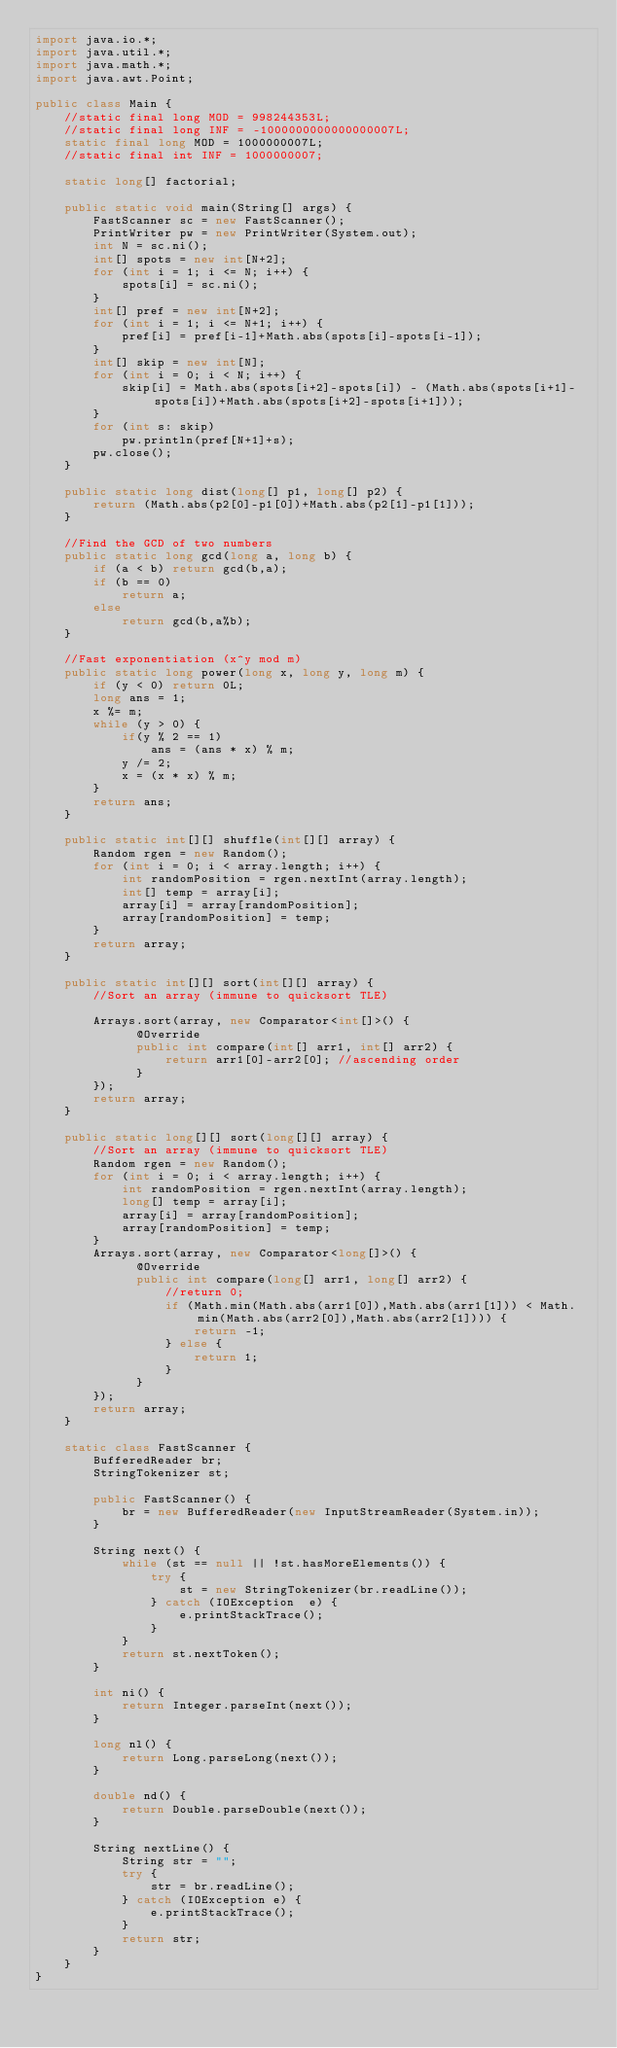<code> <loc_0><loc_0><loc_500><loc_500><_Java_>import java.io.*;
import java.util.*;
import java.math.*;
import java.awt.Point;
 
public class Main {
	//static final long MOD = 998244353L;
	//static final long INF = -1000000000000000007L;
	static final long MOD = 1000000007L;
	//static final int INF = 1000000007;
	
	static long[] factorial;
	
	public static void main(String[] args) {
		FastScanner sc = new FastScanner();
		PrintWriter pw = new PrintWriter(System.out);
		int N = sc.ni();
		int[] spots = new int[N+2];
		for (int i = 1; i <= N; i++) {
			spots[i] = sc.ni();
		}
		int[] pref = new int[N+2];
		for (int i = 1; i <= N+1; i++) {
			pref[i] = pref[i-1]+Math.abs(spots[i]-spots[i-1]);
		}
		int[] skip = new int[N];
		for (int i = 0; i < N; i++) {
			skip[i] = Math.abs(spots[i+2]-spots[i]) - (Math.abs(spots[i+1]-spots[i])+Math.abs(spots[i+2]-spots[i+1]));
		}
		for (int s: skip)
			pw.println(pref[N+1]+s);
		pw.close();
	}
	
	public static long dist(long[] p1, long[] p2) {
		return (Math.abs(p2[0]-p1[0])+Math.abs(p2[1]-p1[1]));
	}
	
	//Find the GCD of two numbers
	public static long gcd(long a, long b) {
		if (a < b) return gcd(b,a);
		if (b == 0)
			return a;
		else
			return gcd(b,a%b);
	}
	
	//Fast exponentiation (x^y mod m)
	public static long power(long x, long y, long m) { 
		if (y < 0) return 0L;
		long ans = 1;
		x %= m;
		while (y > 0) { 
			if(y % 2 == 1) 
				ans = (ans * x) % m; 
			y /= 2;  
			x = (x * x) % m;
		} 
		return ans; 
	}
	
	public static int[][] shuffle(int[][] array) {
		Random rgen = new Random();
		for (int i = 0; i < array.length; i++) {
		    int randomPosition = rgen.nextInt(array.length);
		    int[] temp = array[i];
		    array[i] = array[randomPosition];
		    array[randomPosition] = temp;
		}
		return array;
	}
	
    public static int[][] sort(int[][] array) {
    	//Sort an array (immune to quicksort TLE)
 
		Arrays.sort(array, new Comparator<int[]>() {
			  @Override
        	  public int compare(int[] arr1, int[] arr2) {
				  return arr1[0]-arr2[0]; //ascending order
	          }
		});
		return array;
	}
    
    public static long[][] sort(long[][] array) {
    	//Sort an array (immune to quicksort TLE)
		Random rgen = new Random();
		for (int i = 0; i < array.length; i++) {
		    int randomPosition = rgen.nextInt(array.length);
		    long[] temp = array[i];
		    array[i] = array[randomPosition];
		    array[randomPosition] = temp;
		}
		Arrays.sort(array, new Comparator<long[]>() {
			  @Override
        	  public int compare(long[] arr1, long[] arr2) {
				  //return 0;
				  if (Math.min(Math.abs(arr1[0]),Math.abs(arr1[1])) < Math.min(Math.abs(arr2[0]),Math.abs(arr2[1]))) {
					  return -1;
				  } else {
					  return 1;
				  }
	          }
		});
		return array;
	}
    
    static class FastScanner { 
        BufferedReader br; 
        StringTokenizer st; 
  
        public FastScanner() { 
            br = new BufferedReader(new InputStreamReader(System.in)); 
        } 
  
        String next() { 
            while (st == null || !st.hasMoreElements()) { 
                try { 
                    st = new StringTokenizer(br.readLine());
                } catch (IOException  e) { 
                    e.printStackTrace(); 
                } 
            } 
            return st.nextToken(); 
        } 
  
        int ni() { 
            return Integer.parseInt(next()); 
        } 
  
        long nl() { 
            return Long.parseLong(next()); 
        } 
  
        double nd() { 
            return Double.parseDouble(next()); 
        } 
  
        String nextLine() { 
            String str = ""; 
            try { 
                str = br.readLine(); 
            } catch (IOException e) {
                e.printStackTrace(); 
            } 
            return str;
        }
    }
}</code> 